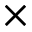Convert formula to latex. <formula><loc_0><loc_0><loc_500><loc_500>\times</formula> 